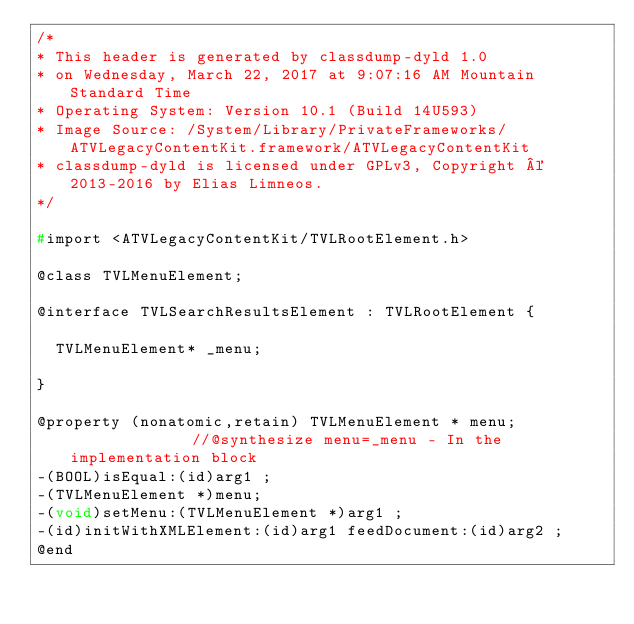<code> <loc_0><loc_0><loc_500><loc_500><_C_>/*
* This header is generated by classdump-dyld 1.0
* on Wednesday, March 22, 2017 at 9:07:16 AM Mountain Standard Time
* Operating System: Version 10.1 (Build 14U593)
* Image Source: /System/Library/PrivateFrameworks/ATVLegacyContentKit.framework/ATVLegacyContentKit
* classdump-dyld is licensed under GPLv3, Copyright © 2013-2016 by Elias Limneos.
*/

#import <ATVLegacyContentKit/TVLRootElement.h>

@class TVLMenuElement;

@interface TVLSearchResultsElement : TVLRootElement {

	TVLMenuElement* _menu;

}

@property (nonatomic,retain) TVLMenuElement * menu;              //@synthesize menu=_menu - In the implementation block
-(BOOL)isEqual:(id)arg1 ;
-(TVLMenuElement *)menu;
-(void)setMenu:(TVLMenuElement *)arg1 ;
-(id)initWithXMLElement:(id)arg1 feedDocument:(id)arg2 ;
@end

</code> 